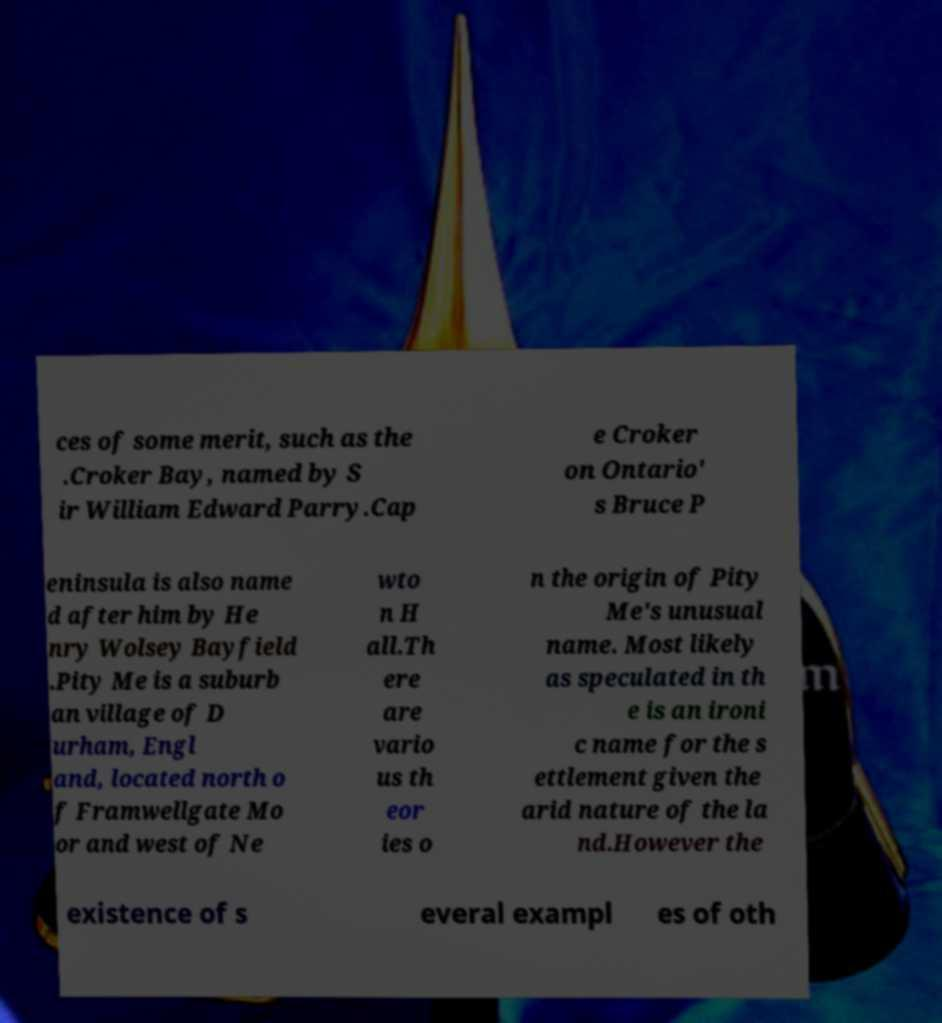I need the written content from this picture converted into text. Can you do that? ces of some merit, such as the .Croker Bay, named by S ir William Edward Parry.Cap e Croker on Ontario' s Bruce P eninsula is also name d after him by He nry Wolsey Bayfield .Pity Me is a suburb an village of D urham, Engl and, located north o f Framwellgate Mo or and west of Ne wto n H all.Th ere are vario us th eor ies o n the origin of Pity Me's unusual name. Most likely as speculated in th e is an ironi c name for the s ettlement given the arid nature of the la nd.However the existence of s everal exampl es of oth 